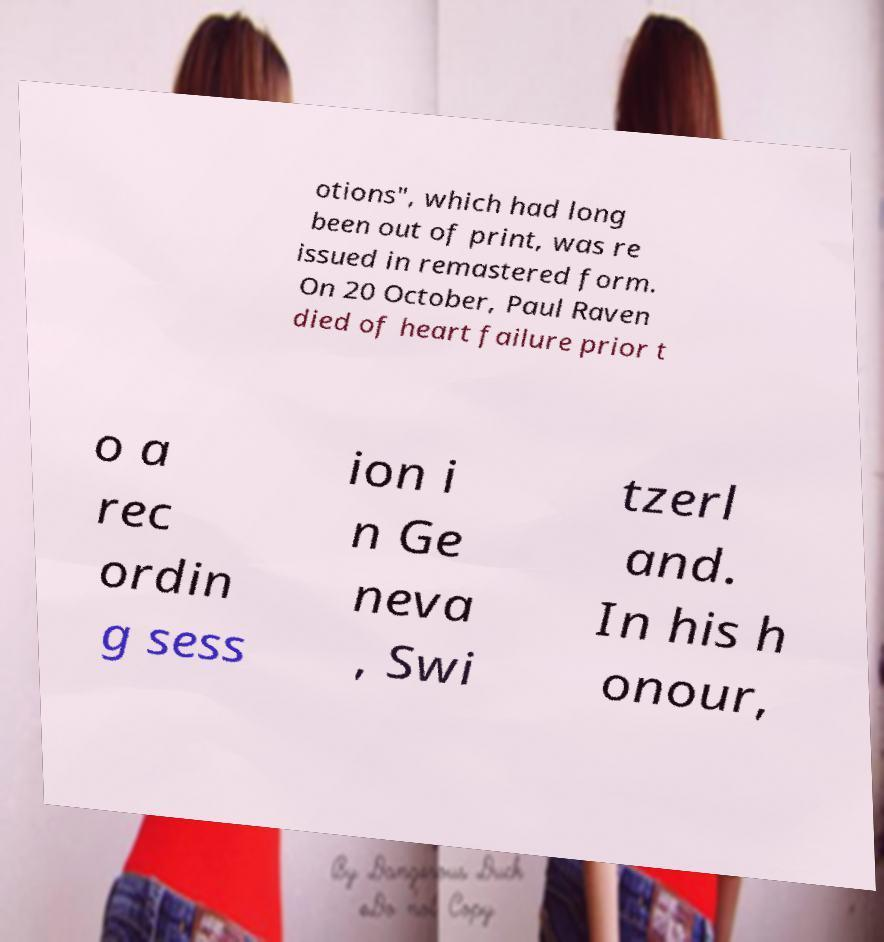What messages or text are displayed in this image? I need them in a readable, typed format. otions", which had long been out of print, was re issued in remastered form. On 20 October, Paul Raven died of heart failure prior t o a rec ordin g sess ion i n Ge neva , Swi tzerl and. In his h onour, 